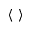Convert formula to latex. <formula><loc_0><loc_0><loc_500><loc_500>\langle \rangle</formula> 